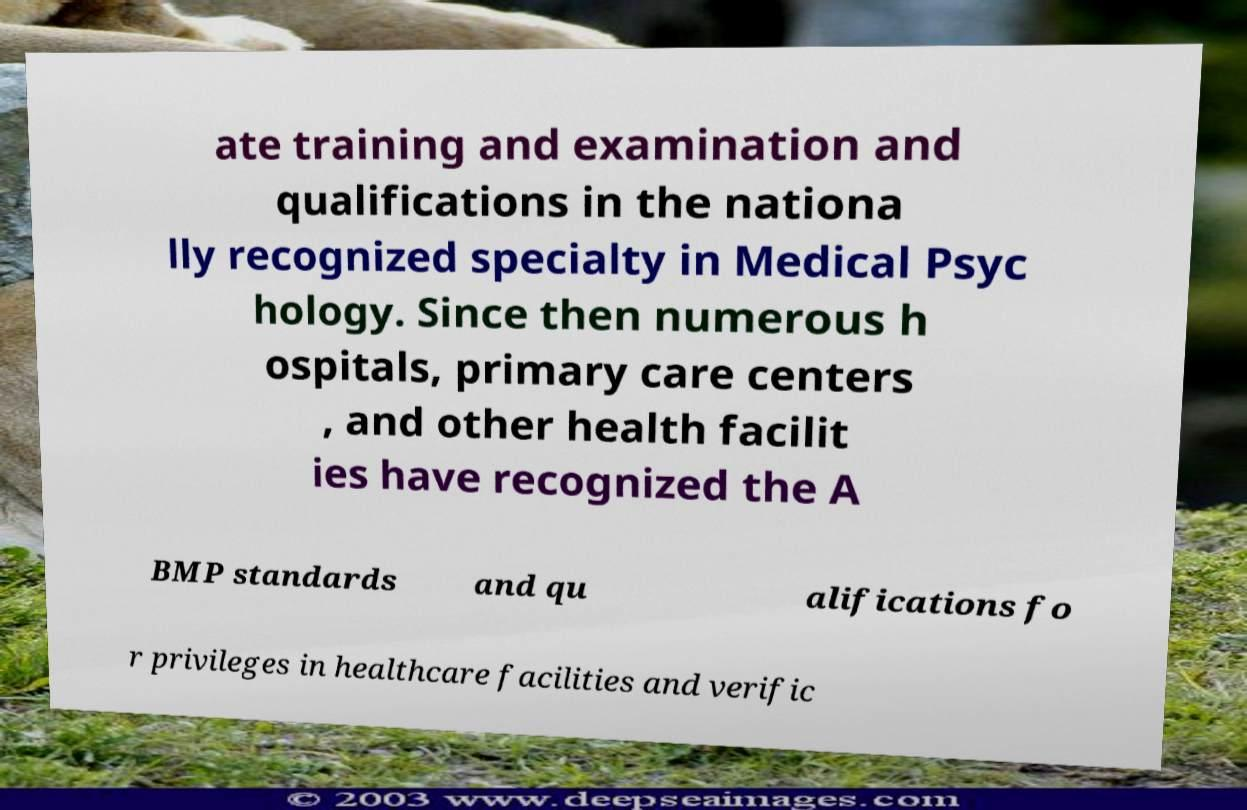Can you accurately transcribe the text from the provided image for me? ate training and examination and qualifications in the nationa lly recognized specialty in Medical Psyc hology. Since then numerous h ospitals, primary care centers , and other health facilit ies have recognized the A BMP standards and qu alifications fo r privileges in healthcare facilities and verific 